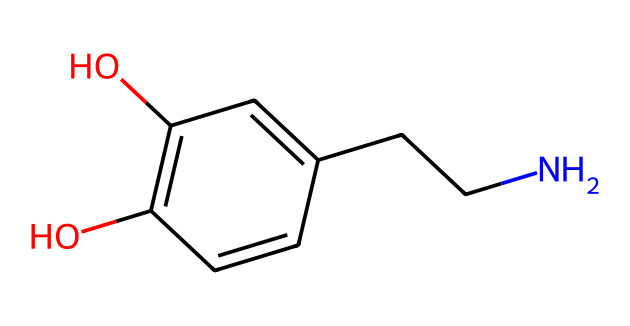What is the molecular formula of this chemical? To find the molecular formula, we need to count the number of each type of atom in the chemical structure represented by the SMILES. From the SMILES, we observe there are 10 carbon atoms (C), 13 hydrogen atoms (H), 1 nitrogen atom (N), and 3 oxygen atoms (O). Therefore, the molecular formula is C10H13N3O3.
Answer: C10H13N3O3 How many hydroxyl (-OH) groups are present in this compound? By examining the chemical structure provided in the SMILES, we can identify the hydroxyl groups as parts of the compound where oxygen is bonded to hydrogen (represented by "O"). In this structure, there are two -OH groups, indicated by the two oxygen atoms directly bonded to hydrogen atoms in the ring structure.
Answer: 2 What type of chemical is this compound classified as? The presence of a carbon atom bonded to a nitrogen atom and functional groups such as hydroxyls suggests this is an amine or an aromatic compound with alcohols. Given its structure, this compound is classified primarily as a phenolic compound.
Answer: phenolic How many rings are present in this chemical structure? To determine the number of rings in the structure, we look for closed loops formed by carbon atoms in the SMILES. The arrangement indicates that there is one aromatic ring which is part of the phenolic structure. Thus, there is one ring present.
Answer: 1 What is the significance of the nitrogen atom in this compound? The nitrogen atom in the structure indicates that this compound is an amine, which is important for neurotransmissions. It contributes to the function of dopamine as it is essential for the synthesis and signaling of neurotransmitters in the brain.
Answer: amine 